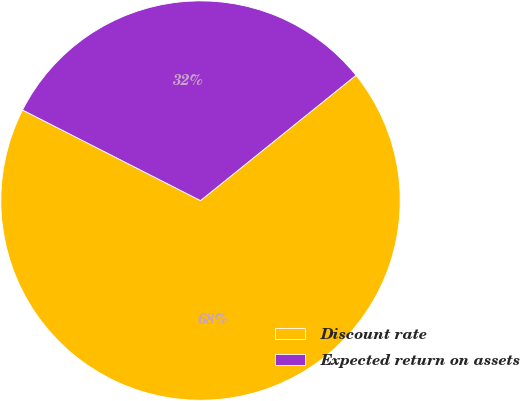Convert chart to OTSL. <chart><loc_0><loc_0><loc_500><loc_500><pie_chart><fcel>Discount rate<fcel>Expected return on assets<nl><fcel>68.29%<fcel>31.71%<nl></chart> 